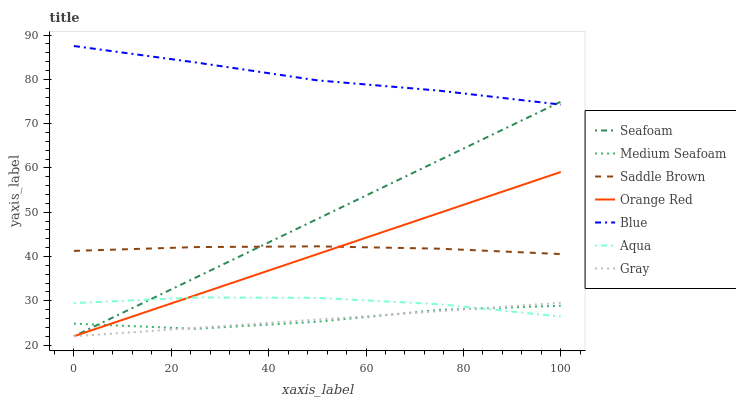Does Gray have the minimum area under the curve?
Answer yes or no. Yes. Does Blue have the maximum area under the curve?
Answer yes or no. Yes. Does Aqua have the minimum area under the curve?
Answer yes or no. No. Does Aqua have the maximum area under the curve?
Answer yes or no. No. Is Seafoam the smoothest?
Answer yes or no. Yes. Is Medium Seafoam the roughest?
Answer yes or no. Yes. Is Gray the smoothest?
Answer yes or no. No. Is Gray the roughest?
Answer yes or no. No. Does Gray have the lowest value?
Answer yes or no. Yes. Does Aqua have the lowest value?
Answer yes or no. No. Does Blue have the highest value?
Answer yes or no. Yes. Does Gray have the highest value?
Answer yes or no. No. Is Aqua less than Saddle Brown?
Answer yes or no. Yes. Is Blue greater than Gray?
Answer yes or no. Yes. Does Seafoam intersect Medium Seafoam?
Answer yes or no. Yes. Is Seafoam less than Medium Seafoam?
Answer yes or no. No. Is Seafoam greater than Medium Seafoam?
Answer yes or no. No. Does Aqua intersect Saddle Brown?
Answer yes or no. No. 